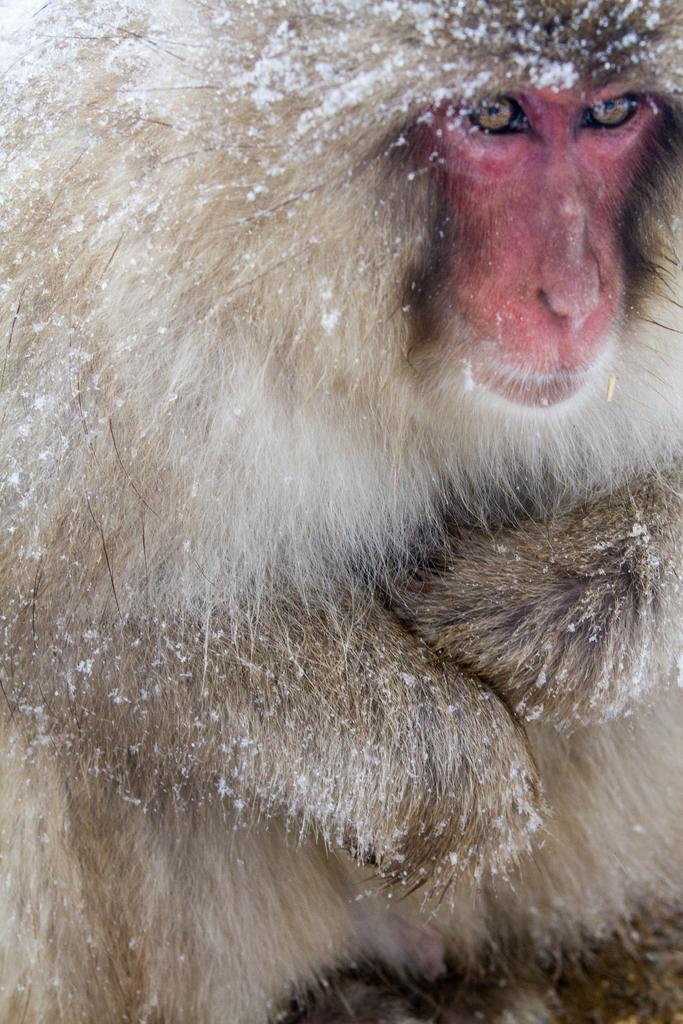What type of animal is present in the image? There is a monkey in the image. What historical events are depicted in the image involving chairs and a town? There are no historical events, chairs, or towns present in the image; it features a monkey. 